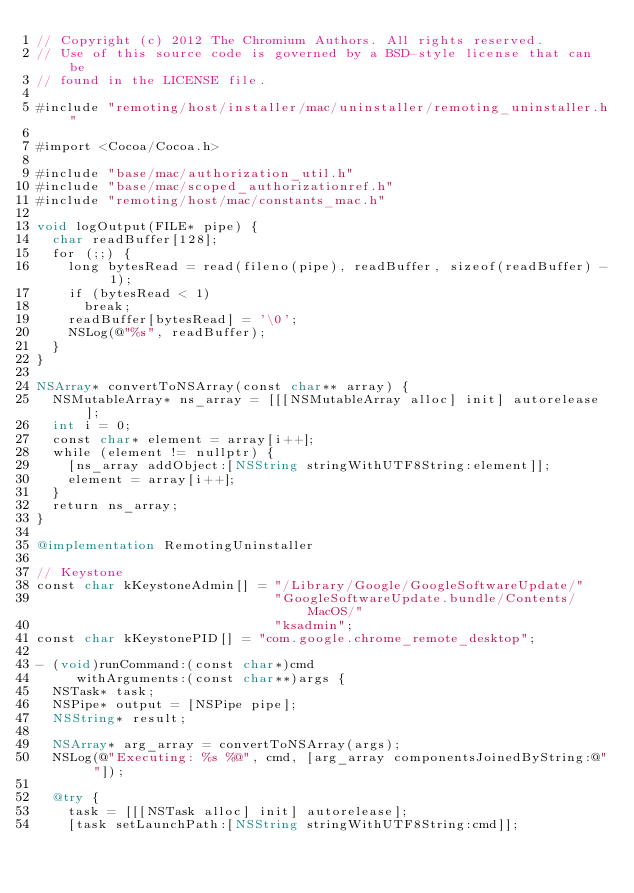Convert code to text. <code><loc_0><loc_0><loc_500><loc_500><_ObjectiveC_>// Copyright (c) 2012 The Chromium Authors. All rights reserved.
// Use of this source code is governed by a BSD-style license that can be
// found in the LICENSE file.

#include "remoting/host/installer/mac/uninstaller/remoting_uninstaller.h"

#import <Cocoa/Cocoa.h>

#include "base/mac/authorization_util.h"
#include "base/mac/scoped_authorizationref.h"
#include "remoting/host/mac/constants_mac.h"

void logOutput(FILE* pipe) {
  char readBuffer[128];
  for (;;) {
    long bytesRead = read(fileno(pipe), readBuffer, sizeof(readBuffer) - 1);
    if (bytesRead < 1)
      break;
    readBuffer[bytesRead] = '\0';
    NSLog(@"%s", readBuffer);
  }
}

NSArray* convertToNSArray(const char** array) {
  NSMutableArray* ns_array = [[[NSMutableArray alloc] init] autorelease];
  int i = 0;
  const char* element = array[i++];
  while (element != nullptr) {
    [ns_array addObject:[NSString stringWithUTF8String:element]];
    element = array[i++];
  }
  return ns_array;
}

@implementation RemotingUninstaller

// Keystone
const char kKeystoneAdmin[] = "/Library/Google/GoogleSoftwareUpdate/"
                              "GoogleSoftwareUpdate.bundle/Contents/MacOS/"
                              "ksadmin";
const char kKeystonePID[] = "com.google.chrome_remote_desktop";

- (void)runCommand:(const char*)cmd
     withArguments:(const char**)args {
  NSTask* task;
  NSPipe* output = [NSPipe pipe];
  NSString* result;

  NSArray* arg_array = convertToNSArray(args);
  NSLog(@"Executing: %s %@", cmd, [arg_array componentsJoinedByString:@" "]);

  @try {
    task = [[[NSTask alloc] init] autorelease];
    [task setLaunchPath:[NSString stringWithUTF8String:cmd]];</code> 